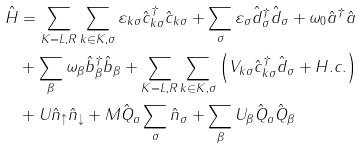<formula> <loc_0><loc_0><loc_500><loc_500>\hat { H } & = \sum _ { K = L , R } \sum _ { k \in K , \sigma } \varepsilon _ { k \sigma } \hat { c } ^ { \dagger } _ { k \sigma } \hat { c } _ { k \sigma } + \sum _ { \sigma } \varepsilon _ { \sigma } \hat { d } ^ { \dagger } _ { \sigma } \hat { d } _ { \sigma } + \omega _ { 0 } \hat { a } ^ { \dagger } \hat { a } \\ & + \sum _ { \beta } \omega _ { \beta } \hat { b } ^ { \dagger } _ { \beta } \hat { b } _ { \beta } + \sum _ { K = L , R } \sum _ { k \in K , \sigma } \left ( V _ { k \sigma } \hat { c } ^ { \dagger } _ { k \sigma } \hat { d } _ { \sigma } + H . c . \right ) \\ & + U \hat { n } _ { \uparrow } \hat { n } _ { \downarrow } + M \hat { Q } _ { a } \sum _ { \sigma } \hat { n } _ { \sigma } + \sum _ { \beta } U _ { \beta } \hat { Q } _ { a } \hat { Q } _ { \beta }</formula> 